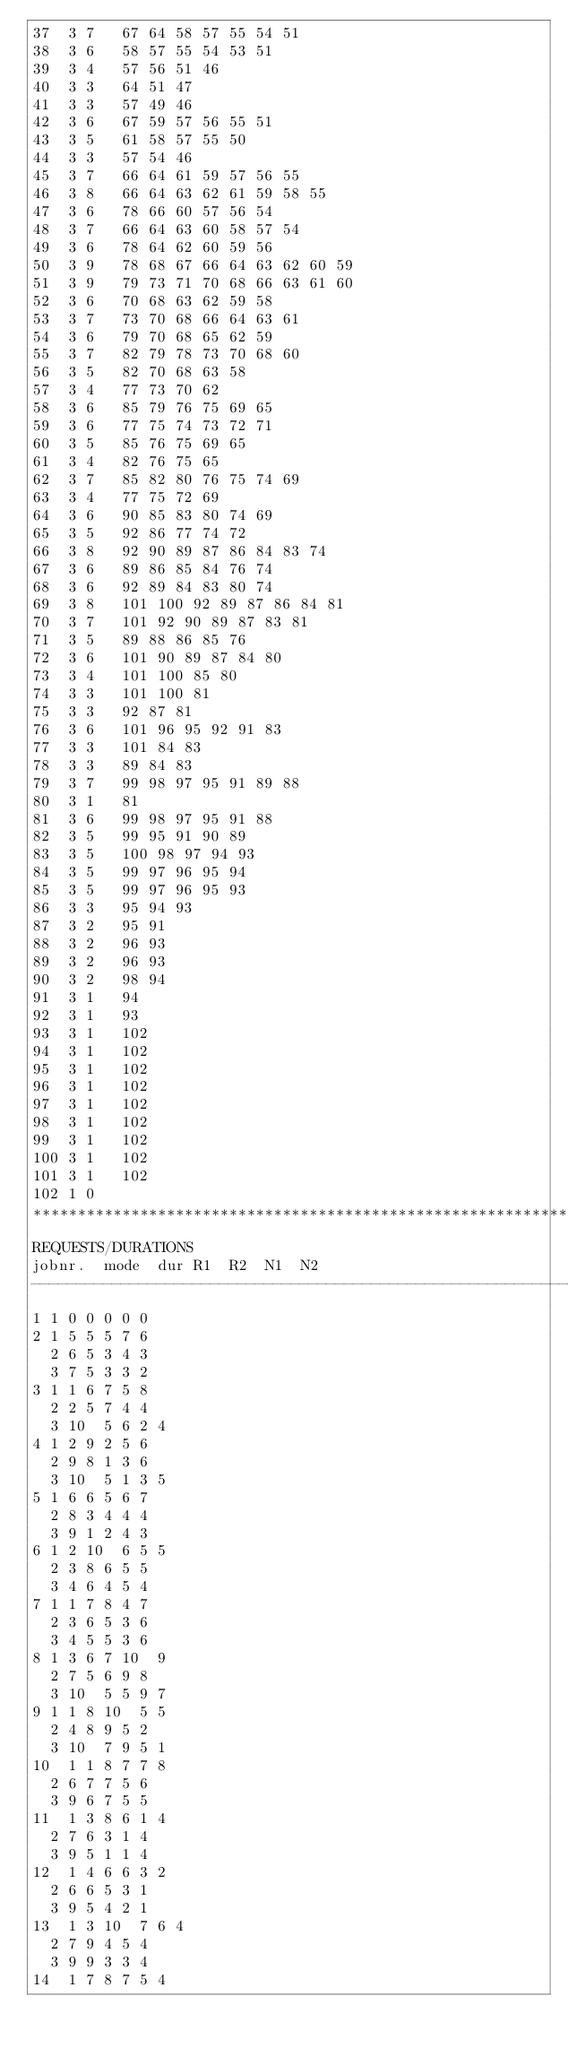<code> <loc_0><loc_0><loc_500><loc_500><_ObjectiveC_>37	3	7		67 64 58 57 55 54 51 
38	3	6		58 57 55 54 53 51 
39	3	4		57 56 51 46 
40	3	3		64 51 47 
41	3	3		57 49 46 
42	3	6		67 59 57 56 55 51 
43	3	5		61 58 57 55 50 
44	3	3		57 54 46 
45	3	7		66 64 61 59 57 56 55 
46	3	8		66 64 63 62 61 59 58 55 
47	3	6		78 66 60 57 56 54 
48	3	7		66 64 63 60 58 57 54 
49	3	6		78 64 62 60 59 56 
50	3	9		78 68 67 66 64 63 62 60 59 
51	3	9		79 73 71 70 68 66 63 61 60 
52	3	6		70 68 63 62 59 58 
53	3	7		73 70 68 66 64 63 61 
54	3	6		79 70 68 65 62 59 
55	3	7		82 79 78 73 70 68 60 
56	3	5		82 70 68 63 58 
57	3	4		77 73 70 62 
58	3	6		85 79 76 75 69 65 
59	3	6		77 75 74 73 72 71 
60	3	5		85 76 75 69 65 
61	3	4		82 76 75 65 
62	3	7		85 82 80 76 75 74 69 
63	3	4		77 75 72 69 
64	3	6		90 85 83 80 74 69 
65	3	5		92 86 77 74 72 
66	3	8		92 90 89 87 86 84 83 74 
67	3	6		89 86 85 84 76 74 
68	3	6		92 89 84 83 80 74 
69	3	8		101 100 92 89 87 86 84 81 
70	3	7		101 92 90 89 87 83 81 
71	3	5		89 88 86 85 76 
72	3	6		101 90 89 87 84 80 
73	3	4		101 100 85 80 
74	3	3		101 100 81 
75	3	3		92 87 81 
76	3	6		101 96 95 92 91 83 
77	3	3		101 84 83 
78	3	3		89 84 83 
79	3	7		99 98 97 95 91 89 88 
80	3	1		81 
81	3	6		99 98 97 95 91 88 
82	3	5		99 95 91 90 89 
83	3	5		100 98 97 94 93 
84	3	5		99 97 96 95 94 
85	3	5		99 97 96 95 93 
86	3	3		95 94 93 
87	3	2		95 91 
88	3	2		96 93 
89	3	2		96 93 
90	3	2		98 94 
91	3	1		94 
92	3	1		93 
93	3	1		102 
94	3	1		102 
95	3	1		102 
96	3	1		102 
97	3	1		102 
98	3	1		102 
99	3	1		102 
100	3	1		102 
101	3	1		102 
102	1	0		
************************************************************************
REQUESTS/DURATIONS
jobnr.	mode	dur	R1	R2	N1	N2	
------------------------------------------------------------------------
1	1	0	0	0	0	0	
2	1	5	5	5	7	6	
	2	6	5	3	4	3	
	3	7	5	3	3	2	
3	1	1	6	7	5	8	
	2	2	5	7	4	4	
	3	10	5	6	2	4	
4	1	2	9	2	5	6	
	2	9	8	1	3	6	
	3	10	5	1	3	5	
5	1	6	6	5	6	7	
	2	8	3	4	4	4	
	3	9	1	2	4	3	
6	1	2	10	6	5	5	
	2	3	8	6	5	5	
	3	4	6	4	5	4	
7	1	1	7	8	4	7	
	2	3	6	5	3	6	
	3	4	5	5	3	6	
8	1	3	6	7	10	9	
	2	7	5	6	9	8	
	3	10	5	5	9	7	
9	1	1	8	10	5	5	
	2	4	8	9	5	2	
	3	10	7	9	5	1	
10	1	1	8	7	7	8	
	2	6	7	7	5	6	
	3	9	6	7	5	5	
11	1	3	8	6	1	4	
	2	7	6	3	1	4	
	3	9	5	1	1	4	
12	1	4	6	6	3	2	
	2	6	6	5	3	1	
	3	9	5	4	2	1	
13	1	3	10	7	6	4	
	2	7	9	4	5	4	
	3	9	9	3	3	4	
14	1	7	8	7	5	4	</code> 